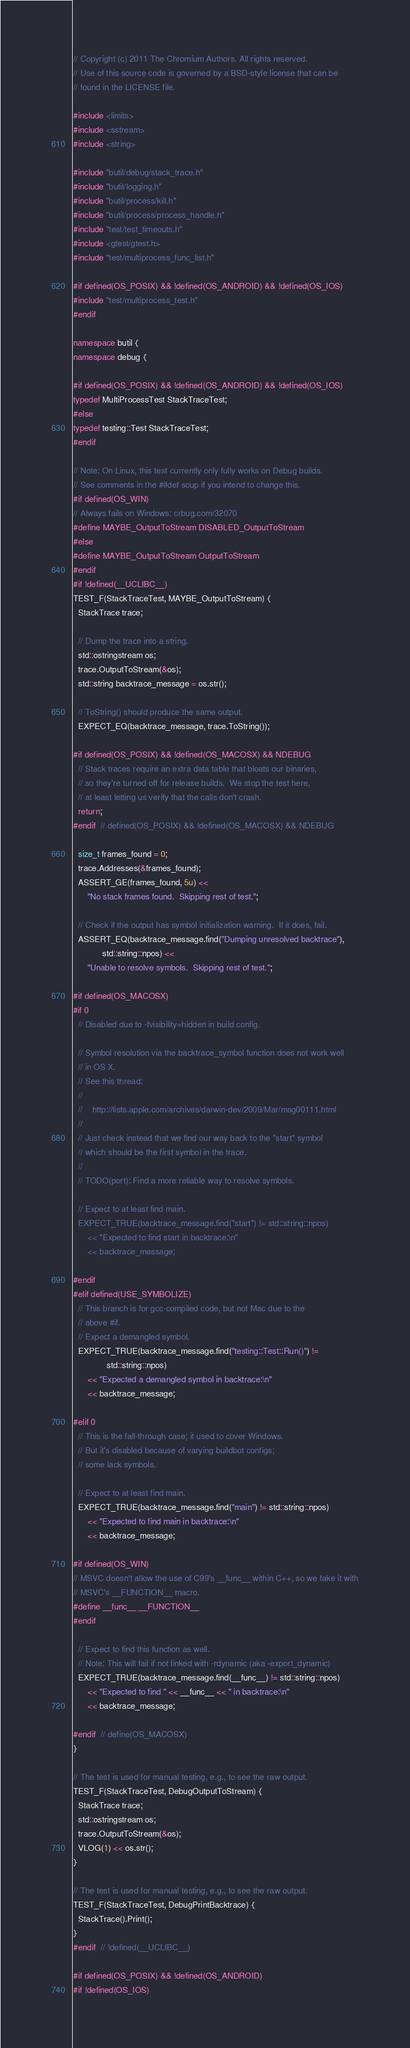Convert code to text. <code><loc_0><loc_0><loc_500><loc_500><_C++_>// Copyright (c) 2011 The Chromium Authors. All rights reserved.
// Use of this source code is governed by a BSD-style license that can be
// found in the LICENSE file.

#include <limits>
#include <sstream>
#include <string>

#include "butil/debug/stack_trace.h"
#include "butil/logging.h"
#include "butil/process/kill.h"
#include "butil/process/process_handle.h"
#include "test/test_timeouts.h"
#include <gtest/gtest.h>
#include "test/multiprocess_func_list.h"

#if defined(OS_POSIX) && !defined(OS_ANDROID) && !defined(OS_IOS)
#include "test/multiprocess_test.h"
#endif

namespace butil {
namespace debug {

#if defined(OS_POSIX) && !defined(OS_ANDROID) && !defined(OS_IOS)
typedef MultiProcessTest StackTraceTest;
#else
typedef testing::Test StackTraceTest;
#endif

// Note: On Linux, this test currently only fully works on Debug builds.
// See comments in the #ifdef soup if you intend to change this.
#if defined(OS_WIN)
// Always fails on Windows: crbug.com/32070
#define MAYBE_OutputToStream DISABLED_OutputToStream
#else
#define MAYBE_OutputToStream OutputToStream
#endif
#if !defined(__UCLIBC__)
TEST_F(StackTraceTest, MAYBE_OutputToStream) {
  StackTrace trace;

  // Dump the trace into a string.
  std::ostringstream os;
  trace.OutputToStream(&os);
  std::string backtrace_message = os.str();

  // ToString() should produce the same output.
  EXPECT_EQ(backtrace_message, trace.ToString());

#if defined(OS_POSIX) && !defined(OS_MACOSX) && NDEBUG
  // Stack traces require an extra data table that bloats our binaries,
  // so they're turned off for release builds.  We stop the test here,
  // at least letting us verify that the calls don't crash.
  return;
#endif  // defined(OS_POSIX) && !defined(OS_MACOSX) && NDEBUG

  size_t frames_found = 0;
  trace.Addresses(&frames_found);
  ASSERT_GE(frames_found, 5u) <<
      "No stack frames found.  Skipping rest of test.";

  // Check if the output has symbol initialization warning.  If it does, fail.
  ASSERT_EQ(backtrace_message.find("Dumping unresolved backtrace"),
            std::string::npos) <<
      "Unable to resolve symbols.  Skipping rest of test.";

#if defined(OS_MACOSX)
#if 0
  // Disabled due to -fvisibility=hidden in build config.

  // Symbol resolution via the backtrace_symbol function does not work well
  // in OS X.
  // See this thread:
  //
  //    http://lists.apple.com/archives/darwin-dev/2009/Mar/msg00111.html
  //
  // Just check instead that we find our way back to the "start" symbol
  // which should be the first symbol in the trace.
  //
  // TODO(port): Find a more reliable way to resolve symbols.

  // Expect to at least find main.
  EXPECT_TRUE(backtrace_message.find("start") != std::string::npos)
      << "Expected to find start in backtrace:\n"
      << backtrace_message;

#endif
#elif defined(USE_SYMBOLIZE)
  // This branch is for gcc-compiled code, but not Mac due to the
  // above #if.
  // Expect a demangled symbol.
  EXPECT_TRUE(backtrace_message.find("testing::Test::Run()") !=
              std::string::npos)
      << "Expected a demangled symbol in backtrace:\n"
      << backtrace_message;

#elif 0
  // This is the fall-through case; it used to cover Windows.
  // But it's disabled because of varying buildbot configs;
  // some lack symbols.

  // Expect to at least find main.
  EXPECT_TRUE(backtrace_message.find("main") != std::string::npos)
      << "Expected to find main in backtrace:\n"
      << backtrace_message;

#if defined(OS_WIN)
// MSVC doesn't allow the use of C99's __func__ within C++, so we fake it with
// MSVC's __FUNCTION__ macro.
#define __func__ __FUNCTION__
#endif

  // Expect to find this function as well.
  // Note: This will fail if not linked with -rdynamic (aka -export_dynamic)
  EXPECT_TRUE(backtrace_message.find(__func__) != std::string::npos)
      << "Expected to find " << __func__ << " in backtrace:\n"
      << backtrace_message;

#endif  // define(OS_MACOSX)
}

// The test is used for manual testing, e.g., to see the raw output.
TEST_F(StackTraceTest, DebugOutputToStream) {
  StackTrace trace;
  std::ostringstream os;
  trace.OutputToStream(&os);
  VLOG(1) << os.str();
}

// The test is used for manual testing, e.g., to see the raw output.
TEST_F(StackTraceTest, DebugPrintBacktrace) {
  StackTrace().Print();
}
#endif  // !defined(__UCLIBC__)

#if defined(OS_POSIX) && !defined(OS_ANDROID)
#if !defined(OS_IOS)</code> 